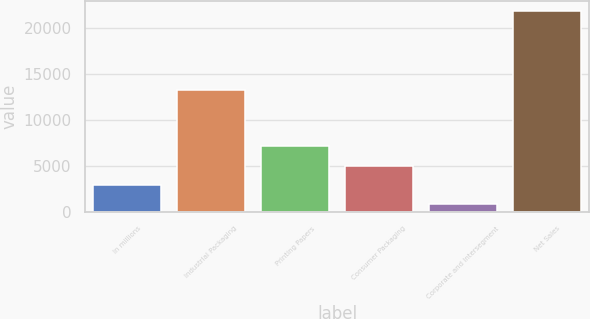<chart> <loc_0><loc_0><loc_500><loc_500><bar_chart><fcel>In millions<fcel>Industrial Packaging<fcel>Printing Papers<fcel>Consumer Packaging<fcel>Corporate and Intersegment<fcel>Net Sales<nl><fcel>2930.4<fcel>13280<fcel>7135.2<fcel>5032.8<fcel>828<fcel>21852<nl></chart> 